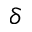<formula> <loc_0><loc_0><loc_500><loc_500>\delta</formula> 